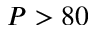<formula> <loc_0><loc_0><loc_500><loc_500>P > 8 0</formula> 